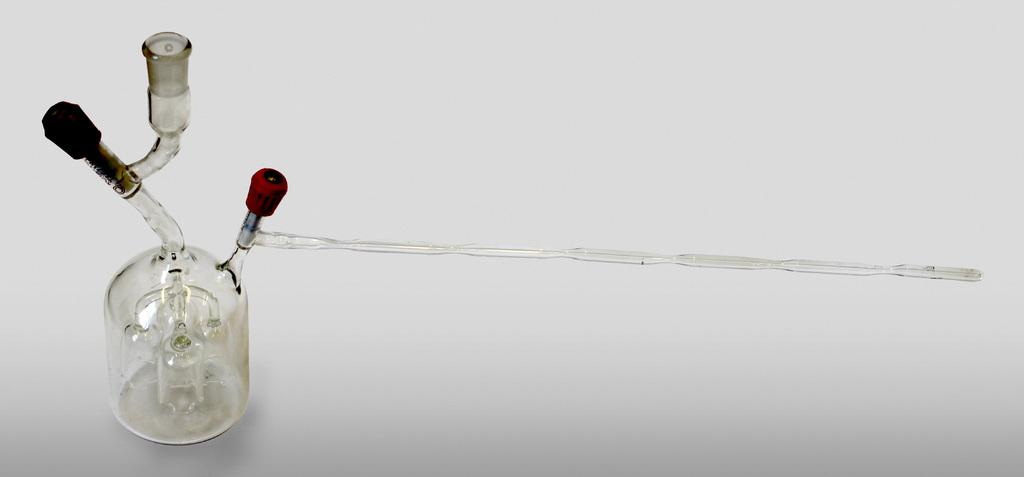What is the main object visible in the image? There is a glass in the image. What type of pest can be seen crawling on the top of the glass in the image? There is no pest present on the top of the glass in the image. 